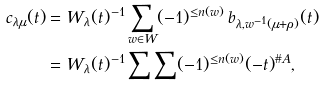<formula> <loc_0><loc_0><loc_500><loc_500>c _ { \lambda \mu } ( t ) & = W _ { \lambda } ( t ) ^ { - 1 } \sum _ { w \in W } ( - 1 ) ^ { \leq n ( w ) } \, b _ { \lambda , w ^ { - 1 } ( \mu + \rho ) } ( t ) \\ & = W _ { \lambda } ( t ) ^ { - 1 } \sum \sum ( - 1 ) ^ { \leq n ( w ) } ( - t ) ^ { \# A } ,</formula> 